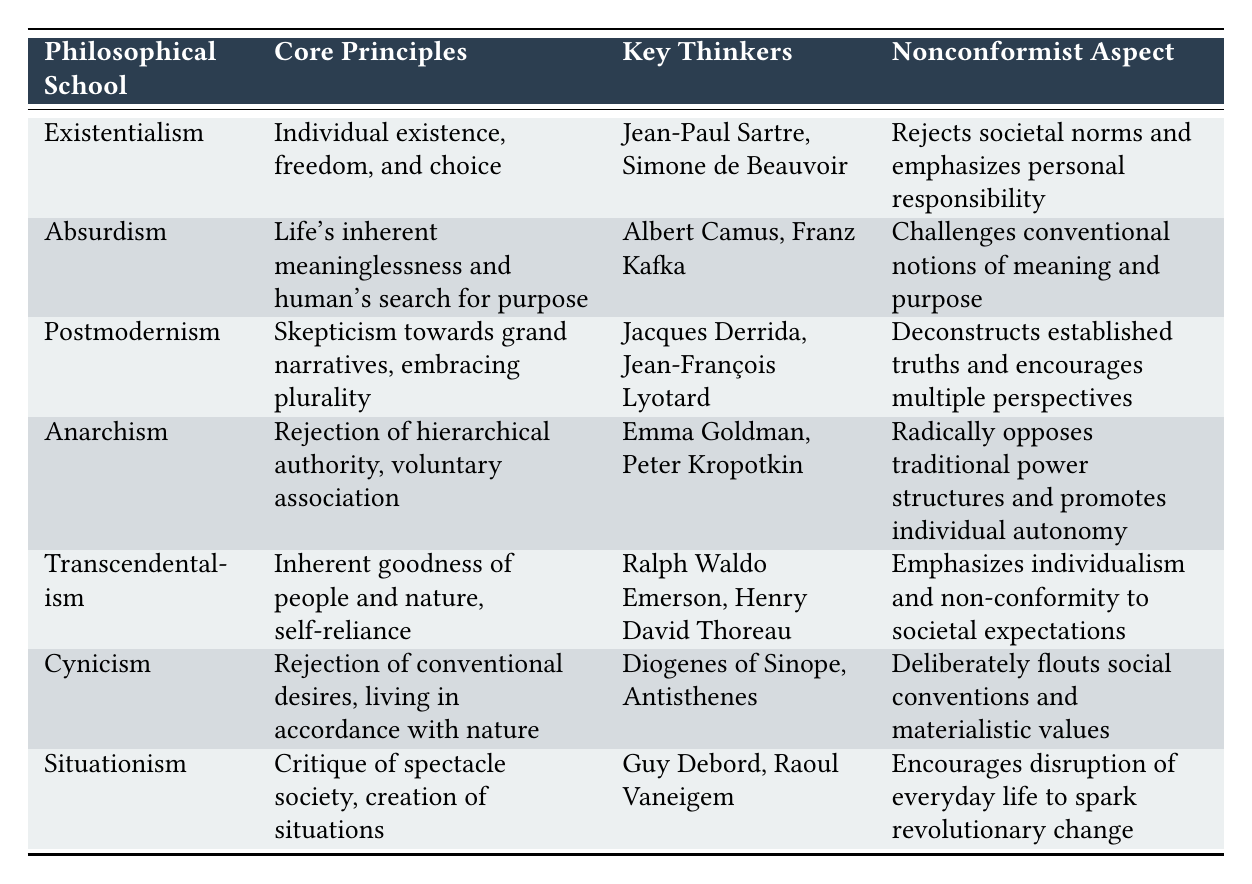What philosophical school emphasizes individual freedom and choice? According to the table, Existentialism is the philosophical school that specifically highlights "Individual existence, freedom, and choice" in its core principles.
Answer: Existentialism Which key thinker is associated with Anarchism? The table lists Emma Goldman and Peter Kropotkin as key thinkers in Anarchism. Therefore, either of them can be identified as a key thinker associated with this school.
Answer: Emma Goldman or Peter Kropotkin Does Cynicism promote materialistic values? The table indicates that Cynicism involves "Rejection of conventional desires" and "living in accordance with nature," which implies a rejection of materialistic values. Hence, the answer is no.
Answer: No Which philosophical school rejects societal norms and emphasizes personal responsibility? The table clearly states that Existentialism involves rejecting societal norms and emphasizes personal responsibility as part of its nonconformist aspect.
Answer: Existentialism What is the core principle of Absurdism? The table states that Absurdism's core principle is "Life's inherent meaninglessness and human's search for purpose." This outlines the fundamental idea behind this philosophical school.
Answer: Life's inherent meaninglessness and human's search for purpose Which philosophical school has a nonconformist aspect that encourages disruption of everyday life? The table identifies Situationism as the school that encourages the disruption of everyday life to spark revolutionary change, highlighting its nonconformist characteristic.
Answer: Situationism Are Ralph Waldo Emerson and Henry David Thoreau key thinkers in Postmodernism? According to the table, these thinkers are associated with Transcendentalism, not Postmodernism, which is linked to Jacques Derrida and Jean-François Lyotard. Thus, the answer is no.
Answer: No How many philosophical schools listed in the table emphasize individualism in their nonconformist aspect? The table shows that Existentialism, Anarchism, and Transcendentalism emphasize individualism in their nonconformist aspects. This makes a total of three schools.
Answer: Three 